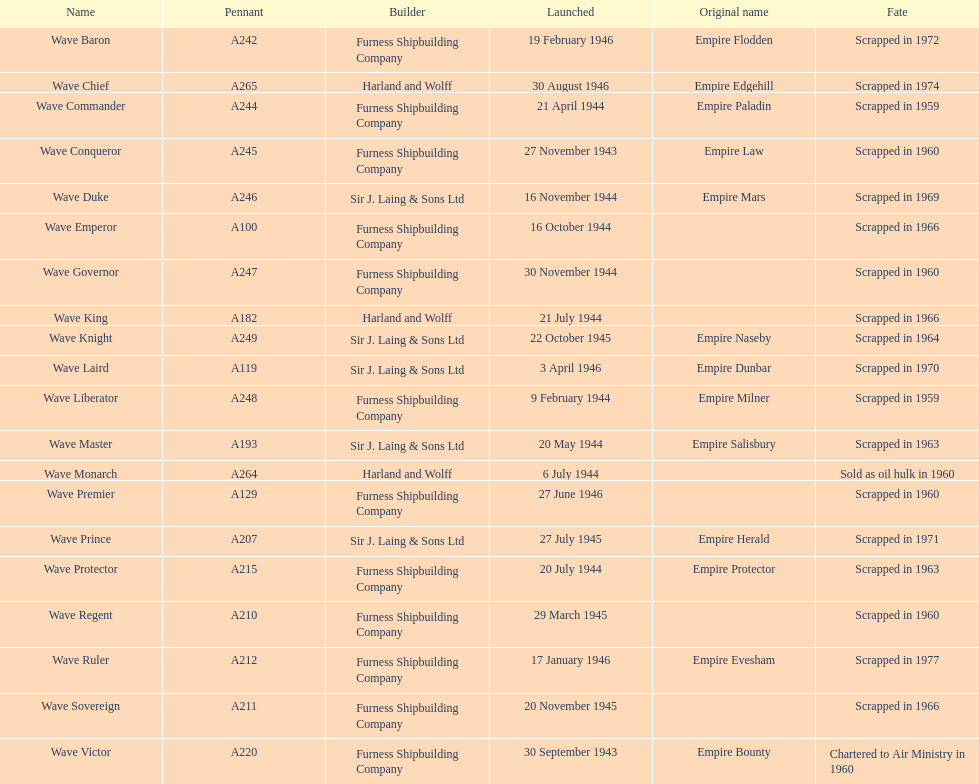What was the date of the first ship's initial launch? 30 September 1943. 